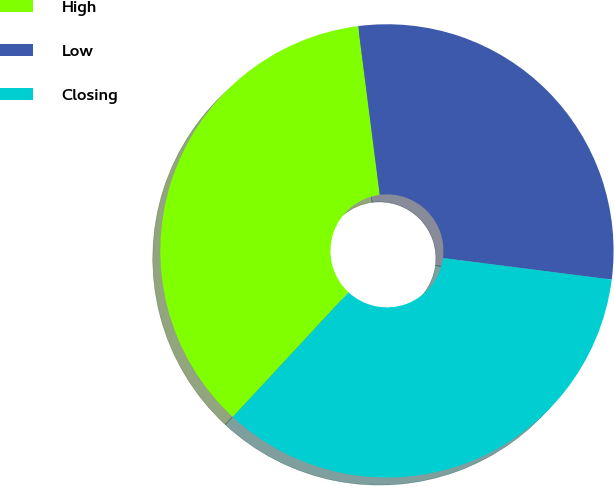Convert chart to OTSL. <chart><loc_0><loc_0><loc_500><loc_500><pie_chart><fcel>High<fcel>Low<fcel>Closing<nl><fcel>36.07%<fcel>29.05%<fcel>34.88%<nl></chart> 